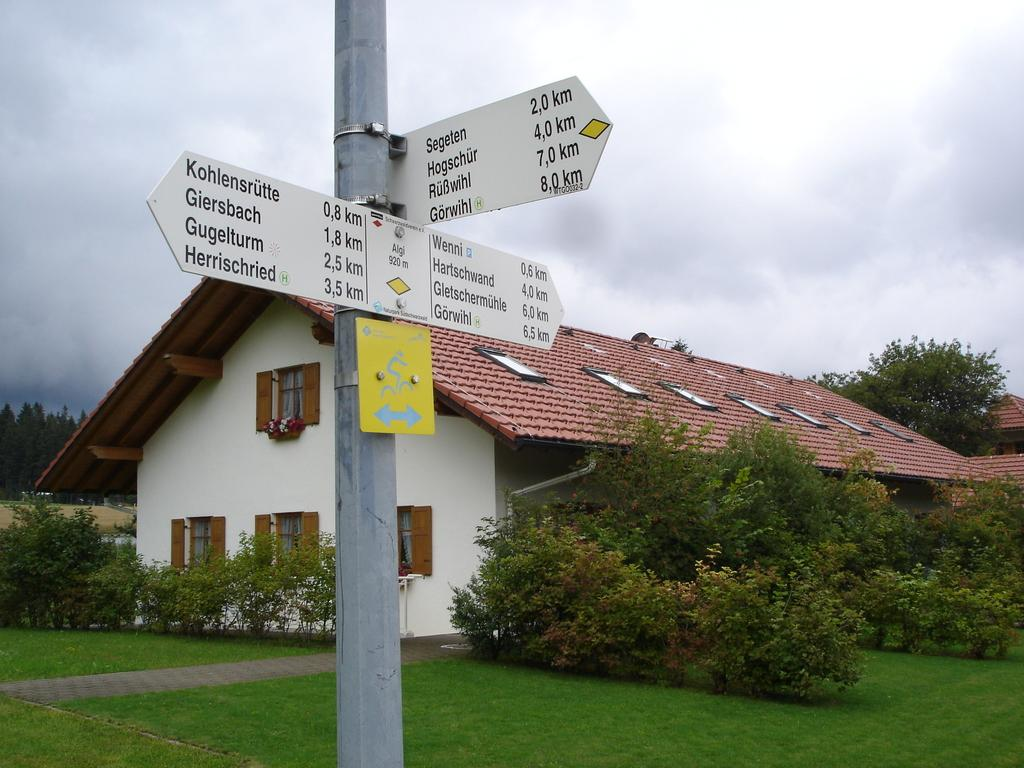<image>
Offer a succinct explanation of the picture presented. a street sign on a pole that says 'kohlensrutte 0,8 km' on it 